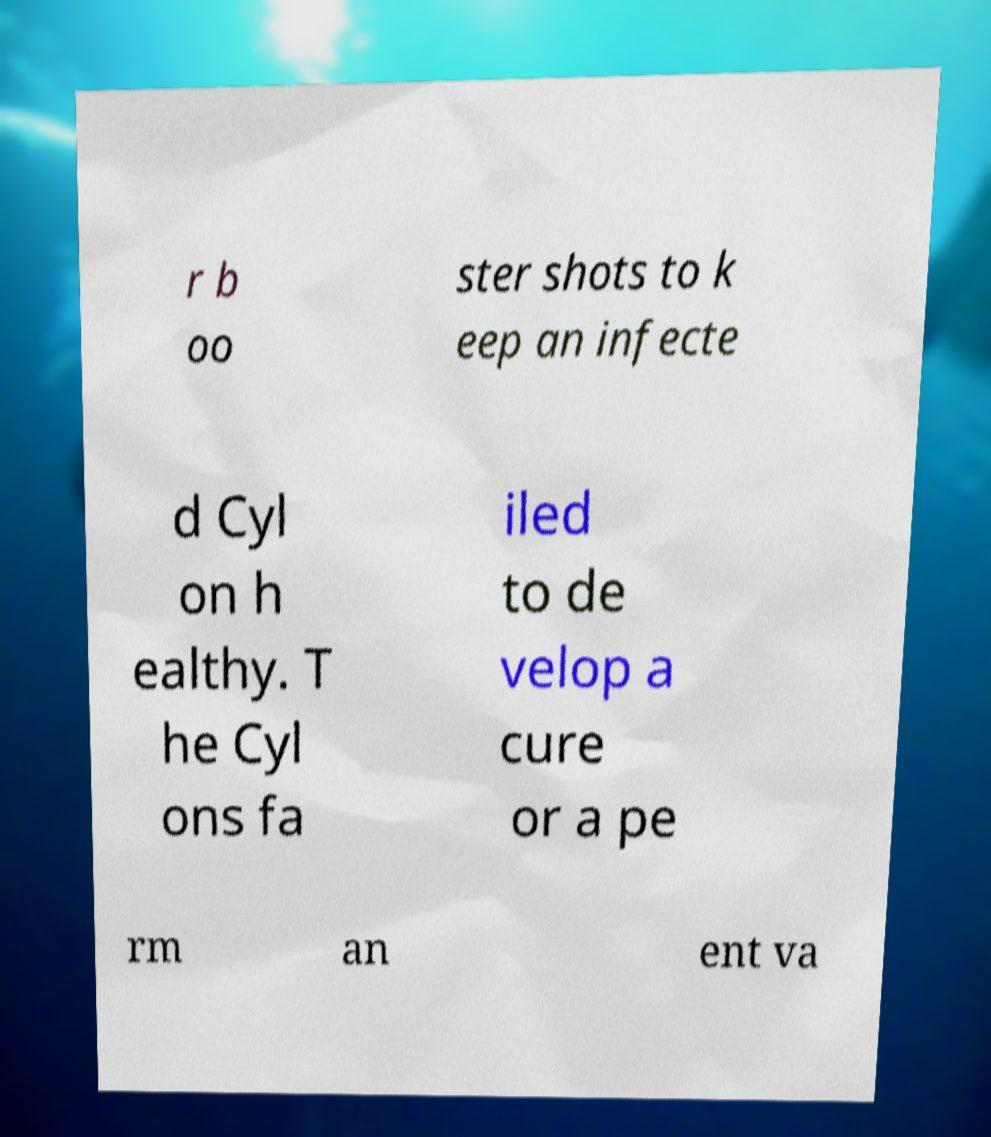Can you read and provide the text displayed in the image?This photo seems to have some interesting text. Can you extract and type it out for me? r b oo ster shots to k eep an infecte d Cyl on h ealthy. T he Cyl ons fa iled to de velop a cure or a pe rm an ent va 